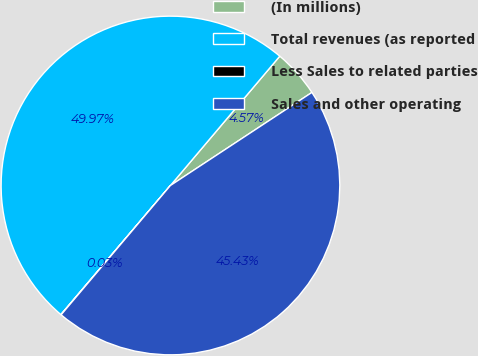Convert chart. <chart><loc_0><loc_0><loc_500><loc_500><pie_chart><fcel>(In millions)<fcel>Total revenues (as reported<fcel>Less Sales to related parties<fcel>Sales and other operating<nl><fcel>4.57%<fcel>49.97%<fcel>0.03%<fcel>45.43%<nl></chart> 